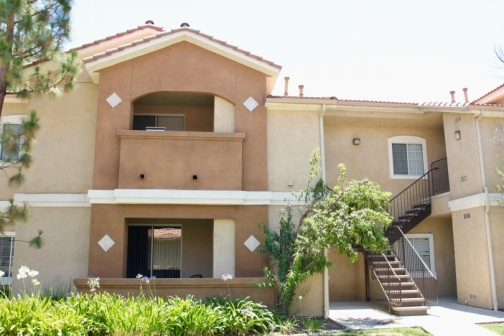Imagine this building in a magical world. What could be happening here? In a magical world, this building could be home to a group of enchantresses who work to maintain balance in the surrounding nature. The balcony could serve as a place to cast protective spells over the garden, and maybe the trees and shrubs are enchanted, contributing to a thriving ecosystem that reacts to the enchantresses' moods. Underneath the patio, hidden passages might lead to secret chambers filled with ancient books and mysterious artifacts. The air would be filled with the faint hum of magic, and occasionally, you might spot a glimmer of fairy wings or hear the soft whispers of enchantments being woven. 